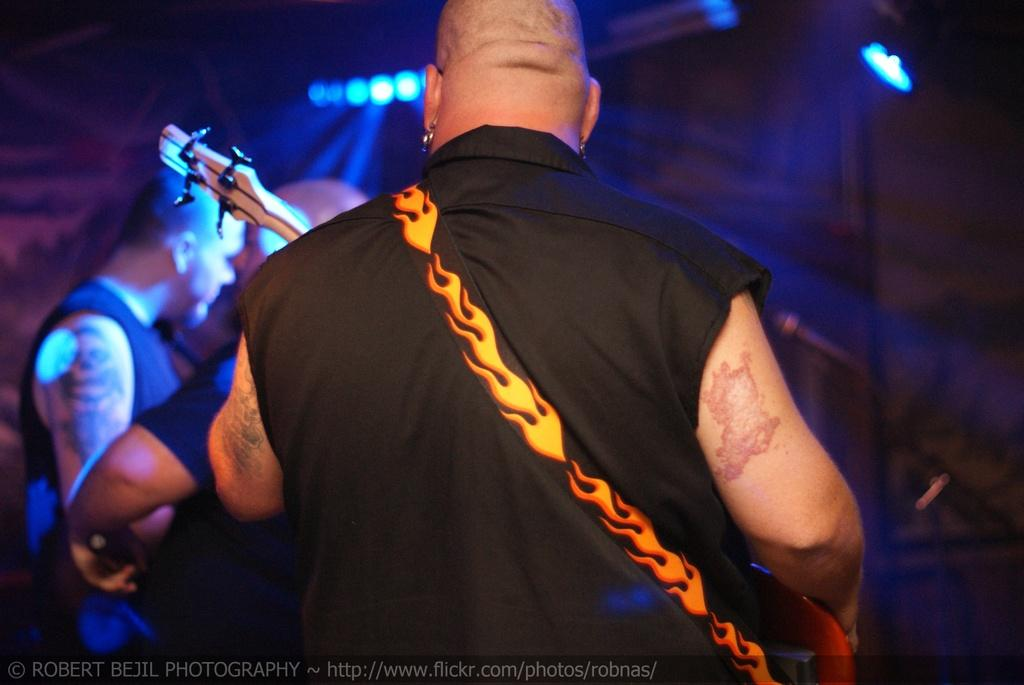How many people are in the image? There are people in the image, but the exact number is not specified. What are the people doing in the image? One of the people is playing a musical instrument. What can be seen on the roof in the image? There are lights on the roof. What is used for amplifying sound in the image? There is a microphone on a stand. What is visible in the sky in the image? There are clouds in the sky. What type of hammer is being used to press the button in the image? There is no hammer or button present in the image. How does the person blow the clouds away in the image? The person does not blow the clouds away in the image; the clouds are a natural part of the sky. 